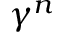<formula> <loc_0><loc_0><loc_500><loc_500>\gamma ^ { n }</formula> 